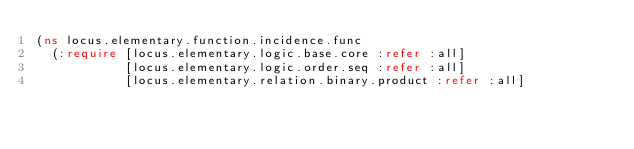Convert code to text. <code><loc_0><loc_0><loc_500><loc_500><_Clojure_>(ns locus.elementary.function.incidence.func
  (:require [locus.elementary.logic.base.core :refer :all]
            [locus.elementary.logic.order.seq :refer :all]
            [locus.elementary.relation.binary.product :refer :all]</code> 